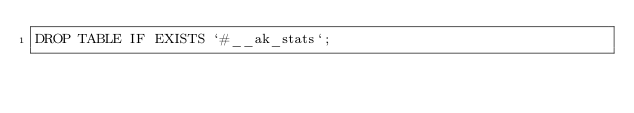Convert code to text. <code><loc_0><loc_0><loc_500><loc_500><_SQL_>DROP TABLE IF EXISTS `#__ak_stats`;
</code> 